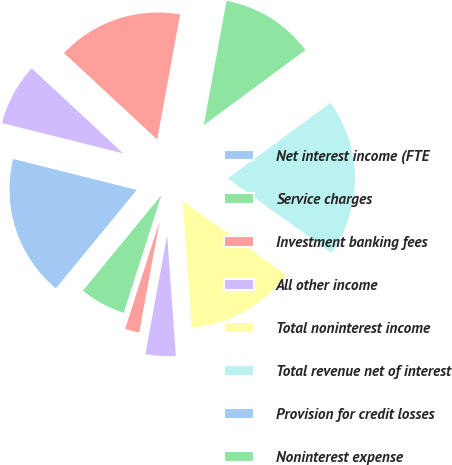Convert chart to OTSL. <chart><loc_0><loc_0><loc_500><loc_500><pie_chart><fcel>Net interest income (FTE<fcel>Service charges<fcel>Investment banking fees<fcel>All other income<fcel>Total noninterest income<fcel>Total revenue net of interest<fcel>Provision for credit losses<fcel>Noninterest expense<fcel>Income before income taxes<fcel>Income tax expense (FTE basis)<nl><fcel>17.96%<fcel>6.02%<fcel>2.04%<fcel>4.03%<fcel>13.98%<fcel>19.96%<fcel>0.04%<fcel>11.99%<fcel>15.97%<fcel>8.01%<nl></chart> 